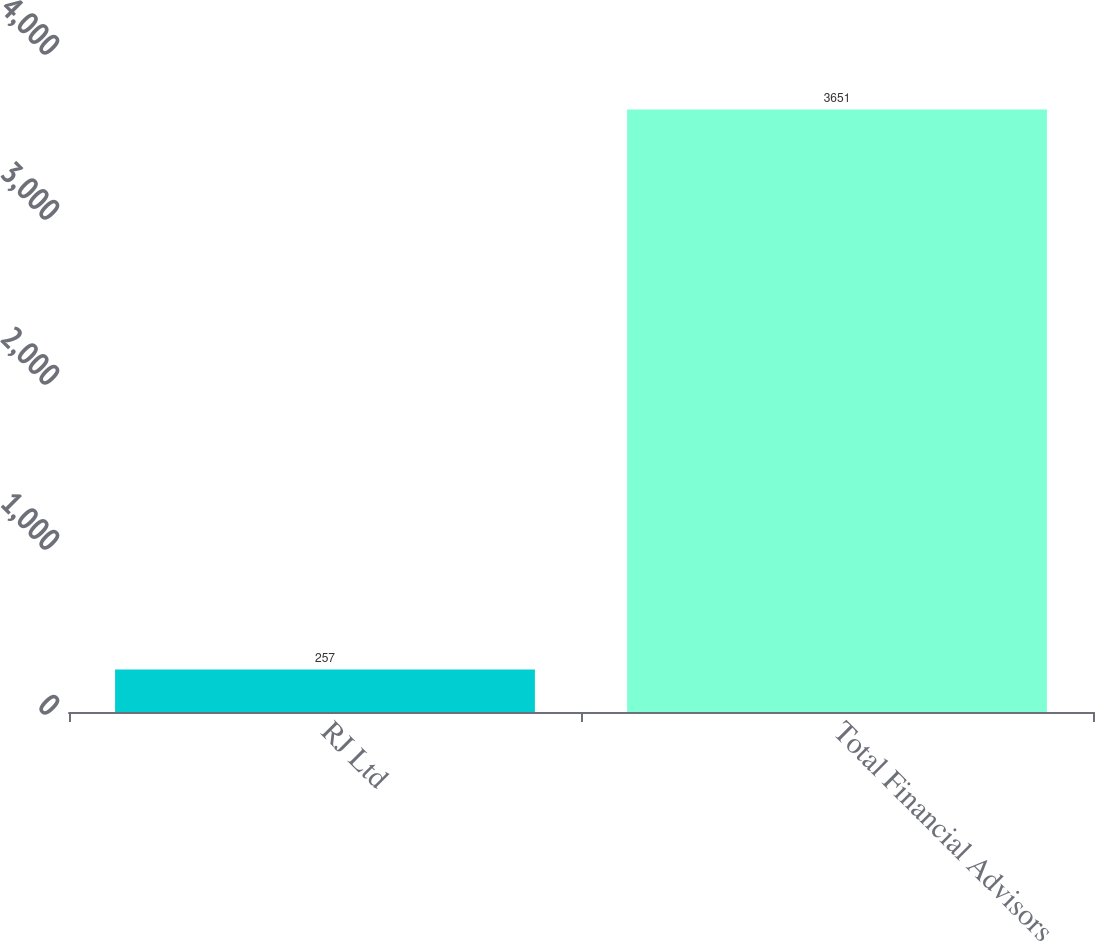Convert chart. <chart><loc_0><loc_0><loc_500><loc_500><bar_chart><fcel>RJ Ltd<fcel>Total Financial Advisors<nl><fcel>257<fcel>3651<nl></chart> 